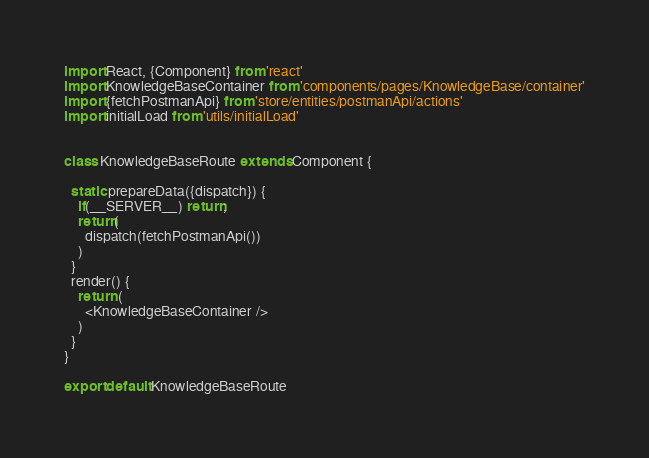Convert code to text. <code><loc_0><loc_0><loc_500><loc_500><_JavaScript_>import React, {Component} from 'react'
import KnowledgeBaseContainer from 'components/pages/KnowledgeBase/container'
import {fetchPostmanApi} from 'store/entities/postmanApi/actions'
import initialLoad from 'utils/initialLoad'


class KnowledgeBaseRoute extends Component {

  static prepareData({dispatch}) {
    if(__SERVER__) return;
    return(
      dispatch(fetchPostmanApi())
    )
  }
  render() {
    return (
      <KnowledgeBaseContainer />
    )
  }
}

export default KnowledgeBaseRoute</code> 